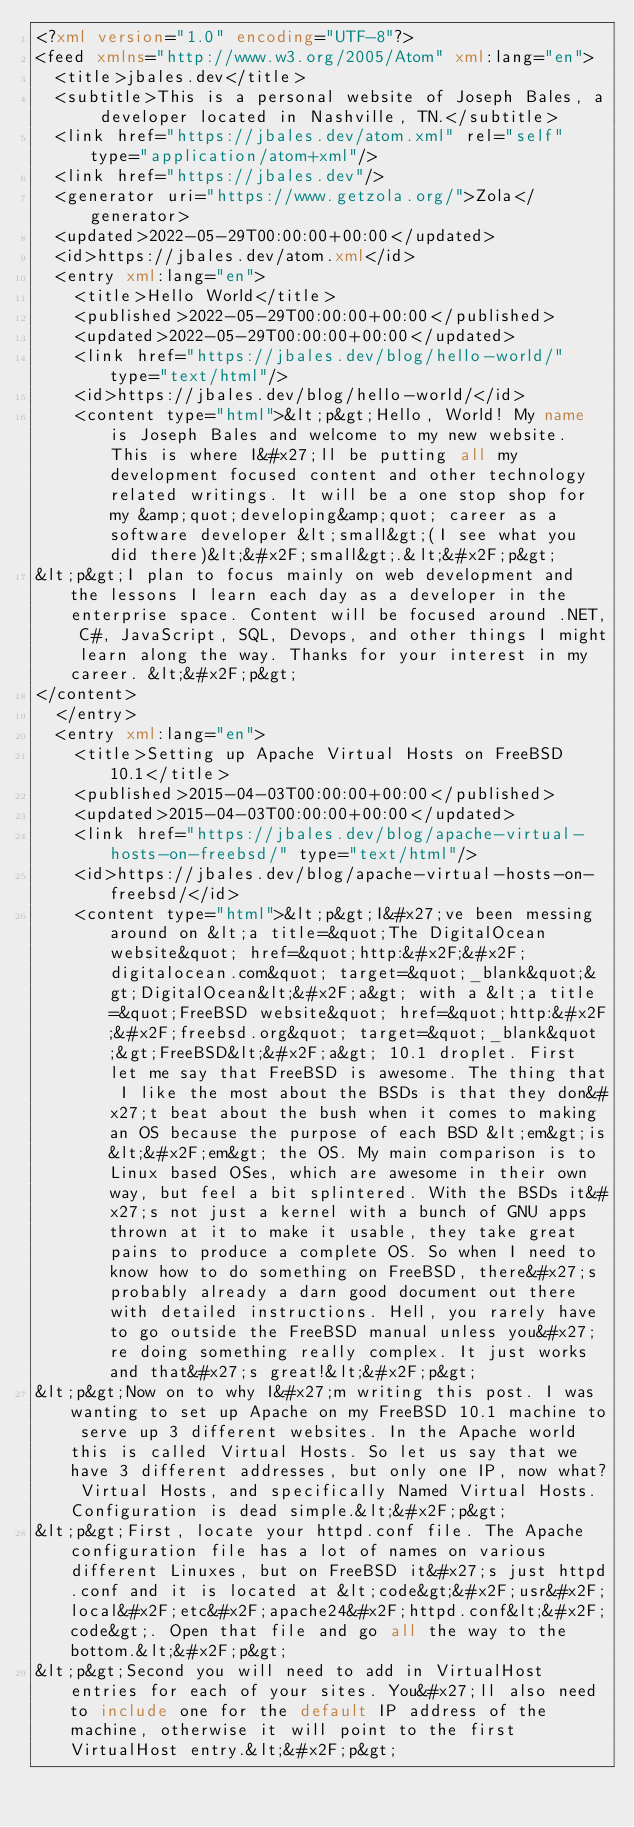Convert code to text. <code><loc_0><loc_0><loc_500><loc_500><_XML_><?xml version="1.0" encoding="UTF-8"?>
<feed xmlns="http://www.w3.org/2005/Atom" xml:lang="en">
	<title>jbales.dev</title>
	<subtitle>This is a personal website of Joseph Bales, a developer located in Nashville, TN.</subtitle>
	<link href="https://jbales.dev/atom.xml" rel="self" type="application/atom+xml"/>
  <link href="https://jbales.dev"/>
	<generator uri="https://www.getzola.org/">Zola</generator>
	<updated>2022-05-29T00:00:00+00:00</updated>
	<id>https://jbales.dev/atom.xml</id>
	<entry xml:lang="en">
		<title>Hello World</title>
		<published>2022-05-29T00:00:00+00:00</published>
		<updated>2022-05-29T00:00:00+00:00</updated>
		<link href="https://jbales.dev/blog/hello-world/" type="text/html"/>
		<id>https://jbales.dev/blog/hello-world/</id>
		<content type="html">&lt;p&gt;Hello, World! My name is Joseph Bales and welcome to my new website. This is where I&#x27;ll be putting all my development focused content and other technology related writings. It will be a one stop shop for my &amp;quot;developing&amp;quot; career as a software developer &lt;small&gt;(I see what you did there)&lt;&#x2F;small&gt;.&lt;&#x2F;p&gt;
&lt;p&gt;I plan to focus mainly on web development and the lessons I learn each day as a developer in the enterprise space. Content will be focused around .NET, C#, JavaScript, SQL, Devops, and other things I might learn along the way. Thanks for your interest in my career. &lt;&#x2F;p&gt;
</content>
	</entry>
	<entry xml:lang="en">
		<title>Setting up Apache Virtual Hosts on FreeBSD 10.1</title>
		<published>2015-04-03T00:00:00+00:00</published>
		<updated>2015-04-03T00:00:00+00:00</updated>
		<link href="https://jbales.dev/blog/apache-virtual-hosts-on-freebsd/" type="text/html"/>
		<id>https://jbales.dev/blog/apache-virtual-hosts-on-freebsd/</id>
		<content type="html">&lt;p&gt;I&#x27;ve been messing around on &lt;a title=&quot;The DigitalOcean website&quot; href=&quot;http:&#x2F;&#x2F;digitalocean.com&quot; target=&quot;_blank&quot;&gt;DigitalOcean&lt;&#x2F;a&gt; with a &lt;a title=&quot;FreeBSD website&quot; href=&quot;http:&#x2F;&#x2F;freebsd.org&quot; target=&quot;_blank&quot;&gt;FreeBSD&lt;&#x2F;a&gt; 10.1 droplet. First let me say that FreeBSD is awesome. The thing that I like the most about the BSDs is that they don&#x27;t beat about the bush when it comes to making an OS because the purpose of each BSD &lt;em&gt;is&lt;&#x2F;em&gt; the OS. My main comparison is to Linux based OSes, which are awesome in their own way, but feel a bit splintered. With the BSDs it&#x27;s not just a kernel with a bunch of GNU apps thrown at it to make it usable, they take great pains to produce a complete OS. So when I need to know how to do something on FreeBSD, there&#x27;s probably already a darn good document out there with detailed instructions. Hell, you rarely have to go outside the FreeBSD manual unless you&#x27;re doing something really complex. It just works and that&#x27;s great!&lt;&#x2F;p&gt;
&lt;p&gt;Now on to why I&#x27;m writing this post. I was wanting to set up Apache on my FreeBSD 10.1 machine to serve up 3 different websites. In the Apache world this is called Virtual Hosts. So let us say that we have 3 different addresses, but only one IP, now what? Virtual Hosts, and specifically Named Virtual Hosts. Configuration is dead simple.&lt;&#x2F;p&gt;
&lt;p&gt;First, locate your httpd.conf file. The Apache configuration file has a lot of names on various different Linuxes, but on FreeBSD it&#x27;s just httpd.conf and it is located at &lt;code&gt;&#x2F;usr&#x2F;local&#x2F;etc&#x2F;apache24&#x2F;httpd.conf&lt;&#x2F;code&gt;. Open that file and go all the way to the bottom.&lt;&#x2F;p&gt;
&lt;p&gt;Second you will need to add in VirtualHost entries for each of your sites. You&#x27;ll also need to include one for the default IP address of the machine, otherwise it will point to the first VirtualHost entry.&lt;&#x2F;p&gt;</code> 